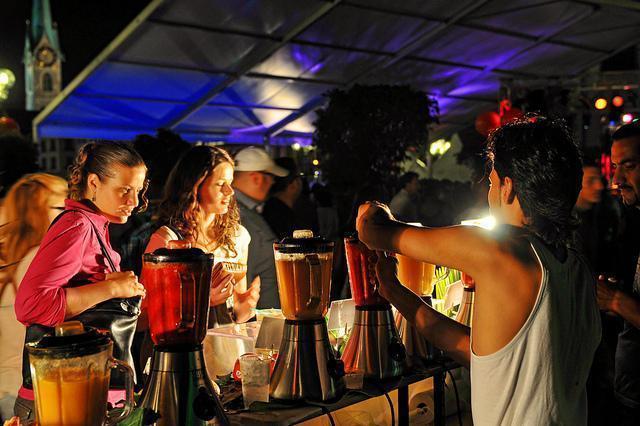What is the boy doing?
Answer the question by selecting the correct answer among the 4 following choices and explain your choice with a short sentence. The answer should be formatted with the following format: `Answer: choice
Rationale: rationale.`
Options: Selling juice, selling blenders, food demonstration, playing magoc. Answer: selling juice.
Rationale: A person is standing behind a counter with a lot of people around. blenders are filled with different colored liquids. 